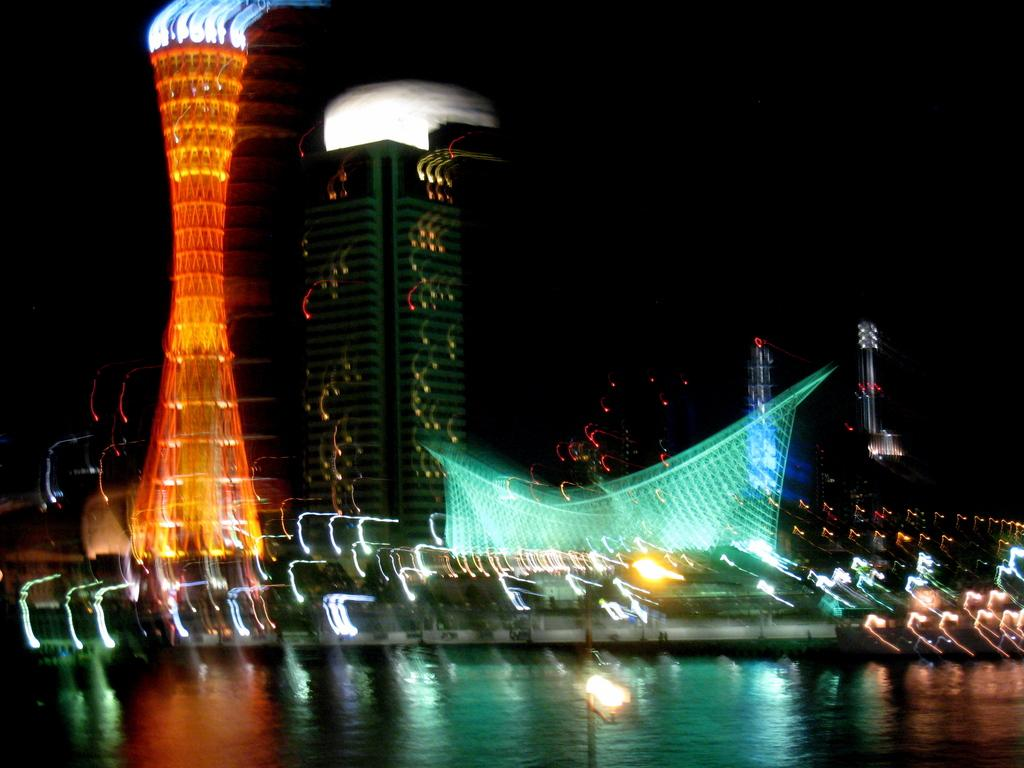What structure can be seen in the image? There is a lamp post in the image. What natural element is visible in the image? There is water visible in the image. What type of structures can be seen behind the water in the image? There are buildings behind the water in the image. What type of bun is floating on the water in the image? There is no bun present in the image. How many clovers can be seen growing near the lamp post in the image? There are no clovers visible in the image. 